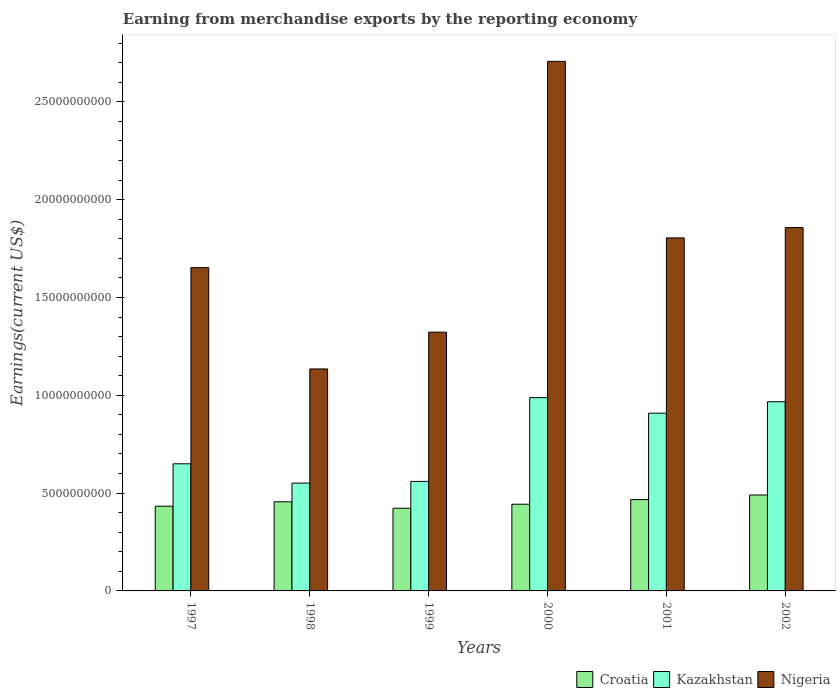How many groups of bars are there?
Provide a succinct answer. 6. Are the number of bars per tick equal to the number of legend labels?
Provide a succinct answer. Yes. How many bars are there on the 4th tick from the left?
Keep it short and to the point. 3. How many bars are there on the 3rd tick from the right?
Offer a very short reply. 3. In how many cases, is the number of bars for a given year not equal to the number of legend labels?
Your response must be concise. 0. What is the amount earned from merchandise exports in Nigeria in 1998?
Ensure brevity in your answer.  1.13e+1. Across all years, what is the maximum amount earned from merchandise exports in Croatia?
Offer a terse response. 4.90e+09. Across all years, what is the minimum amount earned from merchandise exports in Croatia?
Give a very brief answer. 4.23e+09. In which year was the amount earned from merchandise exports in Croatia maximum?
Give a very brief answer. 2002. In which year was the amount earned from merchandise exports in Croatia minimum?
Offer a very short reply. 1999. What is the total amount earned from merchandise exports in Croatia in the graph?
Your answer should be very brief. 2.71e+1. What is the difference between the amount earned from merchandise exports in Croatia in 1997 and that in 1999?
Offer a terse response. 1.06e+08. What is the difference between the amount earned from merchandise exports in Nigeria in 2000 and the amount earned from merchandise exports in Croatia in 1998?
Ensure brevity in your answer.  2.25e+1. What is the average amount earned from merchandise exports in Kazakhstan per year?
Offer a terse response. 7.71e+09. In the year 2002, what is the difference between the amount earned from merchandise exports in Nigeria and amount earned from merchandise exports in Croatia?
Make the answer very short. 1.37e+1. In how many years, is the amount earned from merchandise exports in Kazakhstan greater than 13000000000 US$?
Your response must be concise. 0. What is the ratio of the amount earned from merchandise exports in Nigeria in 1998 to that in 2001?
Give a very brief answer. 0.63. Is the amount earned from merchandise exports in Croatia in 1998 less than that in 2000?
Ensure brevity in your answer.  No. Is the difference between the amount earned from merchandise exports in Nigeria in 1998 and 2001 greater than the difference between the amount earned from merchandise exports in Croatia in 1998 and 2001?
Your answer should be compact. No. What is the difference between the highest and the second highest amount earned from merchandise exports in Croatia?
Your response must be concise. 2.38e+08. What is the difference between the highest and the lowest amount earned from merchandise exports in Kazakhstan?
Make the answer very short. 4.37e+09. Is the sum of the amount earned from merchandise exports in Nigeria in 1999 and 2001 greater than the maximum amount earned from merchandise exports in Kazakhstan across all years?
Make the answer very short. Yes. What does the 2nd bar from the left in 2000 represents?
Your answer should be compact. Kazakhstan. What does the 2nd bar from the right in 2000 represents?
Your answer should be very brief. Kazakhstan. Is it the case that in every year, the sum of the amount earned from merchandise exports in Kazakhstan and amount earned from merchandise exports in Croatia is greater than the amount earned from merchandise exports in Nigeria?
Your response must be concise. No. How many bars are there?
Give a very brief answer. 18. Are all the bars in the graph horizontal?
Give a very brief answer. No. Does the graph contain any zero values?
Offer a terse response. No. Does the graph contain grids?
Your answer should be very brief. No. How many legend labels are there?
Keep it short and to the point. 3. What is the title of the graph?
Your answer should be very brief. Earning from merchandise exports by the reporting economy. What is the label or title of the X-axis?
Offer a very short reply. Years. What is the label or title of the Y-axis?
Provide a short and direct response. Earnings(current US$). What is the Earnings(current US$) of Croatia in 1997?
Your answer should be compact. 4.33e+09. What is the Earnings(current US$) of Kazakhstan in 1997?
Provide a succinct answer. 6.50e+09. What is the Earnings(current US$) of Nigeria in 1997?
Your answer should be very brief. 1.65e+1. What is the Earnings(current US$) of Croatia in 1998?
Your response must be concise. 4.56e+09. What is the Earnings(current US$) of Kazakhstan in 1998?
Keep it short and to the point. 5.51e+09. What is the Earnings(current US$) in Nigeria in 1998?
Keep it short and to the point. 1.13e+1. What is the Earnings(current US$) of Croatia in 1999?
Provide a short and direct response. 4.23e+09. What is the Earnings(current US$) of Kazakhstan in 1999?
Provide a succinct answer. 5.60e+09. What is the Earnings(current US$) in Nigeria in 1999?
Give a very brief answer. 1.32e+1. What is the Earnings(current US$) in Croatia in 2000?
Offer a very short reply. 4.43e+09. What is the Earnings(current US$) in Kazakhstan in 2000?
Offer a very short reply. 9.88e+09. What is the Earnings(current US$) in Nigeria in 2000?
Make the answer very short. 2.71e+1. What is the Earnings(current US$) of Croatia in 2001?
Your answer should be very brief. 4.67e+09. What is the Earnings(current US$) in Kazakhstan in 2001?
Give a very brief answer. 9.09e+09. What is the Earnings(current US$) of Nigeria in 2001?
Your answer should be very brief. 1.80e+1. What is the Earnings(current US$) of Croatia in 2002?
Ensure brevity in your answer.  4.90e+09. What is the Earnings(current US$) of Kazakhstan in 2002?
Give a very brief answer. 9.67e+09. What is the Earnings(current US$) of Nigeria in 2002?
Make the answer very short. 1.86e+1. Across all years, what is the maximum Earnings(current US$) in Croatia?
Your response must be concise. 4.90e+09. Across all years, what is the maximum Earnings(current US$) in Kazakhstan?
Your answer should be very brief. 9.88e+09. Across all years, what is the maximum Earnings(current US$) of Nigeria?
Ensure brevity in your answer.  2.71e+1. Across all years, what is the minimum Earnings(current US$) of Croatia?
Your answer should be compact. 4.23e+09. Across all years, what is the minimum Earnings(current US$) of Kazakhstan?
Offer a terse response. 5.51e+09. Across all years, what is the minimum Earnings(current US$) in Nigeria?
Provide a succinct answer. 1.13e+1. What is the total Earnings(current US$) in Croatia in the graph?
Your answer should be compact. 2.71e+1. What is the total Earnings(current US$) in Kazakhstan in the graph?
Provide a short and direct response. 4.62e+1. What is the total Earnings(current US$) in Nigeria in the graph?
Offer a terse response. 1.05e+11. What is the difference between the Earnings(current US$) of Croatia in 1997 and that in 1998?
Give a very brief answer. -2.25e+08. What is the difference between the Earnings(current US$) of Kazakhstan in 1997 and that in 1998?
Provide a succinct answer. 9.87e+08. What is the difference between the Earnings(current US$) of Nigeria in 1997 and that in 1998?
Offer a very short reply. 5.18e+09. What is the difference between the Earnings(current US$) of Croatia in 1997 and that in 1999?
Provide a succinct answer. 1.06e+08. What is the difference between the Earnings(current US$) of Kazakhstan in 1997 and that in 1999?
Provide a short and direct response. 8.99e+08. What is the difference between the Earnings(current US$) in Nigeria in 1997 and that in 1999?
Keep it short and to the point. 3.30e+09. What is the difference between the Earnings(current US$) of Croatia in 1997 and that in 2000?
Keep it short and to the point. -1.00e+08. What is the difference between the Earnings(current US$) in Kazakhstan in 1997 and that in 2000?
Your answer should be compact. -3.38e+09. What is the difference between the Earnings(current US$) in Nigeria in 1997 and that in 2000?
Your answer should be compact. -1.05e+1. What is the difference between the Earnings(current US$) in Croatia in 1997 and that in 2001?
Give a very brief answer. -3.34e+08. What is the difference between the Earnings(current US$) in Kazakhstan in 1997 and that in 2001?
Provide a short and direct response. -2.59e+09. What is the difference between the Earnings(current US$) of Nigeria in 1997 and that in 2001?
Your answer should be compact. -1.52e+09. What is the difference between the Earnings(current US$) of Croatia in 1997 and that in 2002?
Your answer should be very brief. -5.72e+08. What is the difference between the Earnings(current US$) of Kazakhstan in 1997 and that in 2002?
Provide a short and direct response. -3.17e+09. What is the difference between the Earnings(current US$) of Nigeria in 1997 and that in 2002?
Offer a very short reply. -2.05e+09. What is the difference between the Earnings(current US$) of Croatia in 1998 and that in 1999?
Ensure brevity in your answer.  3.30e+08. What is the difference between the Earnings(current US$) in Kazakhstan in 1998 and that in 1999?
Ensure brevity in your answer.  -8.72e+07. What is the difference between the Earnings(current US$) in Nigeria in 1998 and that in 1999?
Give a very brief answer. -1.88e+09. What is the difference between the Earnings(current US$) of Croatia in 1998 and that in 2000?
Make the answer very short. 1.25e+08. What is the difference between the Earnings(current US$) of Kazakhstan in 1998 and that in 2000?
Make the answer very short. -4.37e+09. What is the difference between the Earnings(current US$) in Nigeria in 1998 and that in 2000?
Your answer should be compact. -1.57e+1. What is the difference between the Earnings(current US$) in Croatia in 1998 and that in 2001?
Ensure brevity in your answer.  -1.09e+08. What is the difference between the Earnings(current US$) in Kazakhstan in 1998 and that in 2001?
Make the answer very short. -3.57e+09. What is the difference between the Earnings(current US$) of Nigeria in 1998 and that in 2001?
Keep it short and to the point. -6.70e+09. What is the difference between the Earnings(current US$) in Croatia in 1998 and that in 2002?
Offer a terse response. -3.47e+08. What is the difference between the Earnings(current US$) in Kazakhstan in 1998 and that in 2002?
Offer a very short reply. -4.16e+09. What is the difference between the Earnings(current US$) in Nigeria in 1998 and that in 2002?
Offer a terse response. -7.23e+09. What is the difference between the Earnings(current US$) of Croatia in 1999 and that in 2000?
Give a very brief answer. -2.06e+08. What is the difference between the Earnings(current US$) of Kazakhstan in 1999 and that in 2000?
Offer a very short reply. -4.28e+09. What is the difference between the Earnings(current US$) in Nigeria in 1999 and that in 2000?
Your answer should be compact. -1.38e+1. What is the difference between the Earnings(current US$) in Croatia in 1999 and that in 2001?
Keep it short and to the point. -4.40e+08. What is the difference between the Earnings(current US$) of Kazakhstan in 1999 and that in 2001?
Your answer should be compact. -3.49e+09. What is the difference between the Earnings(current US$) in Nigeria in 1999 and that in 2001?
Ensure brevity in your answer.  -4.82e+09. What is the difference between the Earnings(current US$) of Croatia in 1999 and that in 2002?
Provide a short and direct response. -6.78e+08. What is the difference between the Earnings(current US$) of Kazakhstan in 1999 and that in 2002?
Give a very brief answer. -4.07e+09. What is the difference between the Earnings(current US$) of Nigeria in 1999 and that in 2002?
Offer a terse response. -5.35e+09. What is the difference between the Earnings(current US$) of Croatia in 2000 and that in 2001?
Ensure brevity in your answer.  -2.34e+08. What is the difference between the Earnings(current US$) in Kazakhstan in 2000 and that in 2001?
Give a very brief answer. 7.95e+08. What is the difference between the Earnings(current US$) in Nigeria in 2000 and that in 2001?
Your answer should be very brief. 9.02e+09. What is the difference between the Earnings(current US$) in Croatia in 2000 and that in 2002?
Your answer should be compact. -4.72e+08. What is the difference between the Earnings(current US$) of Kazakhstan in 2000 and that in 2002?
Keep it short and to the point. 2.09e+08. What is the difference between the Earnings(current US$) in Nigeria in 2000 and that in 2002?
Ensure brevity in your answer.  8.50e+09. What is the difference between the Earnings(current US$) in Croatia in 2001 and that in 2002?
Provide a succinct answer. -2.38e+08. What is the difference between the Earnings(current US$) in Kazakhstan in 2001 and that in 2002?
Keep it short and to the point. -5.85e+08. What is the difference between the Earnings(current US$) in Nigeria in 2001 and that in 2002?
Make the answer very short. -5.27e+08. What is the difference between the Earnings(current US$) of Croatia in 1997 and the Earnings(current US$) of Kazakhstan in 1998?
Give a very brief answer. -1.18e+09. What is the difference between the Earnings(current US$) of Croatia in 1997 and the Earnings(current US$) of Nigeria in 1998?
Give a very brief answer. -7.01e+09. What is the difference between the Earnings(current US$) of Kazakhstan in 1997 and the Earnings(current US$) of Nigeria in 1998?
Your response must be concise. -4.85e+09. What is the difference between the Earnings(current US$) in Croatia in 1997 and the Earnings(current US$) in Kazakhstan in 1999?
Give a very brief answer. -1.27e+09. What is the difference between the Earnings(current US$) in Croatia in 1997 and the Earnings(current US$) in Nigeria in 1999?
Offer a terse response. -8.90e+09. What is the difference between the Earnings(current US$) in Kazakhstan in 1997 and the Earnings(current US$) in Nigeria in 1999?
Your response must be concise. -6.73e+09. What is the difference between the Earnings(current US$) in Croatia in 1997 and the Earnings(current US$) in Kazakhstan in 2000?
Give a very brief answer. -5.55e+09. What is the difference between the Earnings(current US$) of Croatia in 1997 and the Earnings(current US$) of Nigeria in 2000?
Make the answer very short. -2.27e+1. What is the difference between the Earnings(current US$) in Kazakhstan in 1997 and the Earnings(current US$) in Nigeria in 2000?
Your answer should be very brief. -2.06e+1. What is the difference between the Earnings(current US$) of Croatia in 1997 and the Earnings(current US$) of Kazakhstan in 2001?
Provide a short and direct response. -4.75e+09. What is the difference between the Earnings(current US$) in Croatia in 1997 and the Earnings(current US$) in Nigeria in 2001?
Keep it short and to the point. -1.37e+1. What is the difference between the Earnings(current US$) in Kazakhstan in 1997 and the Earnings(current US$) in Nigeria in 2001?
Provide a short and direct response. -1.15e+1. What is the difference between the Earnings(current US$) in Croatia in 1997 and the Earnings(current US$) in Kazakhstan in 2002?
Make the answer very short. -5.34e+09. What is the difference between the Earnings(current US$) of Croatia in 1997 and the Earnings(current US$) of Nigeria in 2002?
Your answer should be very brief. -1.42e+1. What is the difference between the Earnings(current US$) of Kazakhstan in 1997 and the Earnings(current US$) of Nigeria in 2002?
Make the answer very short. -1.21e+1. What is the difference between the Earnings(current US$) of Croatia in 1998 and the Earnings(current US$) of Kazakhstan in 1999?
Provide a short and direct response. -1.04e+09. What is the difference between the Earnings(current US$) of Croatia in 1998 and the Earnings(current US$) of Nigeria in 1999?
Provide a succinct answer. -8.67e+09. What is the difference between the Earnings(current US$) in Kazakhstan in 1998 and the Earnings(current US$) in Nigeria in 1999?
Give a very brief answer. -7.72e+09. What is the difference between the Earnings(current US$) in Croatia in 1998 and the Earnings(current US$) in Kazakhstan in 2000?
Offer a terse response. -5.32e+09. What is the difference between the Earnings(current US$) of Croatia in 1998 and the Earnings(current US$) of Nigeria in 2000?
Provide a short and direct response. -2.25e+1. What is the difference between the Earnings(current US$) of Kazakhstan in 1998 and the Earnings(current US$) of Nigeria in 2000?
Offer a terse response. -2.16e+1. What is the difference between the Earnings(current US$) of Croatia in 1998 and the Earnings(current US$) of Kazakhstan in 2001?
Provide a succinct answer. -4.53e+09. What is the difference between the Earnings(current US$) in Croatia in 1998 and the Earnings(current US$) in Nigeria in 2001?
Your answer should be compact. -1.35e+1. What is the difference between the Earnings(current US$) of Kazakhstan in 1998 and the Earnings(current US$) of Nigeria in 2001?
Offer a very short reply. -1.25e+1. What is the difference between the Earnings(current US$) in Croatia in 1998 and the Earnings(current US$) in Kazakhstan in 2002?
Offer a terse response. -5.11e+09. What is the difference between the Earnings(current US$) of Croatia in 1998 and the Earnings(current US$) of Nigeria in 2002?
Your answer should be very brief. -1.40e+1. What is the difference between the Earnings(current US$) of Kazakhstan in 1998 and the Earnings(current US$) of Nigeria in 2002?
Offer a very short reply. -1.31e+1. What is the difference between the Earnings(current US$) of Croatia in 1999 and the Earnings(current US$) of Kazakhstan in 2000?
Your response must be concise. -5.65e+09. What is the difference between the Earnings(current US$) of Croatia in 1999 and the Earnings(current US$) of Nigeria in 2000?
Your answer should be compact. -2.28e+1. What is the difference between the Earnings(current US$) of Kazakhstan in 1999 and the Earnings(current US$) of Nigeria in 2000?
Keep it short and to the point. -2.15e+1. What is the difference between the Earnings(current US$) of Croatia in 1999 and the Earnings(current US$) of Kazakhstan in 2001?
Offer a terse response. -4.86e+09. What is the difference between the Earnings(current US$) in Croatia in 1999 and the Earnings(current US$) in Nigeria in 2001?
Offer a very short reply. -1.38e+1. What is the difference between the Earnings(current US$) in Kazakhstan in 1999 and the Earnings(current US$) in Nigeria in 2001?
Provide a short and direct response. -1.24e+1. What is the difference between the Earnings(current US$) of Croatia in 1999 and the Earnings(current US$) of Kazakhstan in 2002?
Provide a short and direct response. -5.44e+09. What is the difference between the Earnings(current US$) of Croatia in 1999 and the Earnings(current US$) of Nigeria in 2002?
Offer a very short reply. -1.43e+1. What is the difference between the Earnings(current US$) of Kazakhstan in 1999 and the Earnings(current US$) of Nigeria in 2002?
Your response must be concise. -1.30e+1. What is the difference between the Earnings(current US$) of Croatia in 2000 and the Earnings(current US$) of Kazakhstan in 2001?
Keep it short and to the point. -4.65e+09. What is the difference between the Earnings(current US$) of Croatia in 2000 and the Earnings(current US$) of Nigeria in 2001?
Your answer should be very brief. -1.36e+1. What is the difference between the Earnings(current US$) in Kazakhstan in 2000 and the Earnings(current US$) in Nigeria in 2001?
Ensure brevity in your answer.  -8.16e+09. What is the difference between the Earnings(current US$) of Croatia in 2000 and the Earnings(current US$) of Kazakhstan in 2002?
Provide a succinct answer. -5.24e+09. What is the difference between the Earnings(current US$) in Croatia in 2000 and the Earnings(current US$) in Nigeria in 2002?
Ensure brevity in your answer.  -1.41e+1. What is the difference between the Earnings(current US$) in Kazakhstan in 2000 and the Earnings(current US$) in Nigeria in 2002?
Offer a terse response. -8.69e+09. What is the difference between the Earnings(current US$) in Croatia in 2001 and the Earnings(current US$) in Kazakhstan in 2002?
Ensure brevity in your answer.  -5.00e+09. What is the difference between the Earnings(current US$) in Croatia in 2001 and the Earnings(current US$) in Nigeria in 2002?
Offer a very short reply. -1.39e+1. What is the difference between the Earnings(current US$) of Kazakhstan in 2001 and the Earnings(current US$) of Nigeria in 2002?
Your answer should be very brief. -9.49e+09. What is the average Earnings(current US$) of Croatia per year?
Your response must be concise. 4.52e+09. What is the average Earnings(current US$) in Kazakhstan per year?
Provide a short and direct response. 7.71e+09. What is the average Earnings(current US$) in Nigeria per year?
Provide a succinct answer. 1.75e+1. In the year 1997, what is the difference between the Earnings(current US$) in Croatia and Earnings(current US$) in Kazakhstan?
Your answer should be compact. -2.17e+09. In the year 1997, what is the difference between the Earnings(current US$) in Croatia and Earnings(current US$) in Nigeria?
Your response must be concise. -1.22e+1. In the year 1997, what is the difference between the Earnings(current US$) of Kazakhstan and Earnings(current US$) of Nigeria?
Keep it short and to the point. -1.00e+1. In the year 1998, what is the difference between the Earnings(current US$) of Croatia and Earnings(current US$) of Kazakhstan?
Your answer should be very brief. -9.54e+08. In the year 1998, what is the difference between the Earnings(current US$) of Croatia and Earnings(current US$) of Nigeria?
Give a very brief answer. -6.79e+09. In the year 1998, what is the difference between the Earnings(current US$) in Kazakhstan and Earnings(current US$) in Nigeria?
Make the answer very short. -5.84e+09. In the year 1999, what is the difference between the Earnings(current US$) in Croatia and Earnings(current US$) in Kazakhstan?
Your answer should be very brief. -1.37e+09. In the year 1999, what is the difference between the Earnings(current US$) in Croatia and Earnings(current US$) in Nigeria?
Provide a short and direct response. -9.00e+09. In the year 1999, what is the difference between the Earnings(current US$) in Kazakhstan and Earnings(current US$) in Nigeria?
Your response must be concise. -7.63e+09. In the year 2000, what is the difference between the Earnings(current US$) in Croatia and Earnings(current US$) in Kazakhstan?
Offer a terse response. -5.45e+09. In the year 2000, what is the difference between the Earnings(current US$) in Croatia and Earnings(current US$) in Nigeria?
Offer a very short reply. -2.26e+1. In the year 2000, what is the difference between the Earnings(current US$) of Kazakhstan and Earnings(current US$) of Nigeria?
Provide a succinct answer. -1.72e+1. In the year 2001, what is the difference between the Earnings(current US$) of Croatia and Earnings(current US$) of Kazakhstan?
Your response must be concise. -4.42e+09. In the year 2001, what is the difference between the Earnings(current US$) in Croatia and Earnings(current US$) in Nigeria?
Keep it short and to the point. -1.34e+1. In the year 2001, what is the difference between the Earnings(current US$) of Kazakhstan and Earnings(current US$) of Nigeria?
Your response must be concise. -8.96e+09. In the year 2002, what is the difference between the Earnings(current US$) in Croatia and Earnings(current US$) in Kazakhstan?
Ensure brevity in your answer.  -4.77e+09. In the year 2002, what is the difference between the Earnings(current US$) of Croatia and Earnings(current US$) of Nigeria?
Offer a very short reply. -1.37e+1. In the year 2002, what is the difference between the Earnings(current US$) of Kazakhstan and Earnings(current US$) of Nigeria?
Keep it short and to the point. -8.90e+09. What is the ratio of the Earnings(current US$) in Croatia in 1997 to that in 1998?
Offer a very short reply. 0.95. What is the ratio of the Earnings(current US$) in Kazakhstan in 1997 to that in 1998?
Give a very brief answer. 1.18. What is the ratio of the Earnings(current US$) of Nigeria in 1997 to that in 1998?
Make the answer very short. 1.46. What is the ratio of the Earnings(current US$) of Kazakhstan in 1997 to that in 1999?
Give a very brief answer. 1.16. What is the ratio of the Earnings(current US$) of Nigeria in 1997 to that in 1999?
Ensure brevity in your answer.  1.25. What is the ratio of the Earnings(current US$) in Croatia in 1997 to that in 2000?
Provide a short and direct response. 0.98. What is the ratio of the Earnings(current US$) in Kazakhstan in 1997 to that in 2000?
Provide a short and direct response. 0.66. What is the ratio of the Earnings(current US$) of Nigeria in 1997 to that in 2000?
Keep it short and to the point. 0.61. What is the ratio of the Earnings(current US$) in Croatia in 1997 to that in 2001?
Your response must be concise. 0.93. What is the ratio of the Earnings(current US$) in Kazakhstan in 1997 to that in 2001?
Keep it short and to the point. 0.72. What is the ratio of the Earnings(current US$) of Nigeria in 1997 to that in 2001?
Your answer should be compact. 0.92. What is the ratio of the Earnings(current US$) in Croatia in 1997 to that in 2002?
Ensure brevity in your answer.  0.88. What is the ratio of the Earnings(current US$) in Kazakhstan in 1997 to that in 2002?
Your answer should be compact. 0.67. What is the ratio of the Earnings(current US$) of Nigeria in 1997 to that in 2002?
Offer a very short reply. 0.89. What is the ratio of the Earnings(current US$) of Croatia in 1998 to that in 1999?
Your answer should be compact. 1.08. What is the ratio of the Earnings(current US$) of Kazakhstan in 1998 to that in 1999?
Offer a very short reply. 0.98. What is the ratio of the Earnings(current US$) in Nigeria in 1998 to that in 1999?
Offer a very short reply. 0.86. What is the ratio of the Earnings(current US$) in Croatia in 1998 to that in 2000?
Provide a short and direct response. 1.03. What is the ratio of the Earnings(current US$) of Kazakhstan in 1998 to that in 2000?
Make the answer very short. 0.56. What is the ratio of the Earnings(current US$) of Nigeria in 1998 to that in 2000?
Your response must be concise. 0.42. What is the ratio of the Earnings(current US$) in Croatia in 1998 to that in 2001?
Keep it short and to the point. 0.98. What is the ratio of the Earnings(current US$) of Kazakhstan in 1998 to that in 2001?
Your answer should be compact. 0.61. What is the ratio of the Earnings(current US$) in Nigeria in 1998 to that in 2001?
Your response must be concise. 0.63. What is the ratio of the Earnings(current US$) in Croatia in 1998 to that in 2002?
Keep it short and to the point. 0.93. What is the ratio of the Earnings(current US$) in Kazakhstan in 1998 to that in 2002?
Give a very brief answer. 0.57. What is the ratio of the Earnings(current US$) of Nigeria in 1998 to that in 2002?
Your answer should be compact. 0.61. What is the ratio of the Earnings(current US$) in Croatia in 1999 to that in 2000?
Provide a short and direct response. 0.95. What is the ratio of the Earnings(current US$) of Kazakhstan in 1999 to that in 2000?
Your answer should be compact. 0.57. What is the ratio of the Earnings(current US$) of Nigeria in 1999 to that in 2000?
Your answer should be compact. 0.49. What is the ratio of the Earnings(current US$) in Croatia in 1999 to that in 2001?
Your response must be concise. 0.91. What is the ratio of the Earnings(current US$) in Kazakhstan in 1999 to that in 2001?
Offer a terse response. 0.62. What is the ratio of the Earnings(current US$) of Nigeria in 1999 to that in 2001?
Offer a terse response. 0.73. What is the ratio of the Earnings(current US$) of Croatia in 1999 to that in 2002?
Your answer should be compact. 0.86. What is the ratio of the Earnings(current US$) of Kazakhstan in 1999 to that in 2002?
Give a very brief answer. 0.58. What is the ratio of the Earnings(current US$) of Nigeria in 1999 to that in 2002?
Provide a short and direct response. 0.71. What is the ratio of the Earnings(current US$) of Croatia in 2000 to that in 2001?
Keep it short and to the point. 0.95. What is the ratio of the Earnings(current US$) of Kazakhstan in 2000 to that in 2001?
Provide a succinct answer. 1.09. What is the ratio of the Earnings(current US$) of Nigeria in 2000 to that in 2001?
Your answer should be compact. 1.5. What is the ratio of the Earnings(current US$) in Croatia in 2000 to that in 2002?
Ensure brevity in your answer.  0.9. What is the ratio of the Earnings(current US$) of Kazakhstan in 2000 to that in 2002?
Give a very brief answer. 1.02. What is the ratio of the Earnings(current US$) in Nigeria in 2000 to that in 2002?
Offer a terse response. 1.46. What is the ratio of the Earnings(current US$) of Croatia in 2001 to that in 2002?
Your response must be concise. 0.95. What is the ratio of the Earnings(current US$) in Kazakhstan in 2001 to that in 2002?
Ensure brevity in your answer.  0.94. What is the ratio of the Earnings(current US$) of Nigeria in 2001 to that in 2002?
Ensure brevity in your answer.  0.97. What is the difference between the highest and the second highest Earnings(current US$) in Croatia?
Offer a very short reply. 2.38e+08. What is the difference between the highest and the second highest Earnings(current US$) of Kazakhstan?
Offer a very short reply. 2.09e+08. What is the difference between the highest and the second highest Earnings(current US$) in Nigeria?
Your answer should be very brief. 8.50e+09. What is the difference between the highest and the lowest Earnings(current US$) in Croatia?
Your response must be concise. 6.78e+08. What is the difference between the highest and the lowest Earnings(current US$) in Kazakhstan?
Provide a succinct answer. 4.37e+09. What is the difference between the highest and the lowest Earnings(current US$) in Nigeria?
Provide a succinct answer. 1.57e+1. 